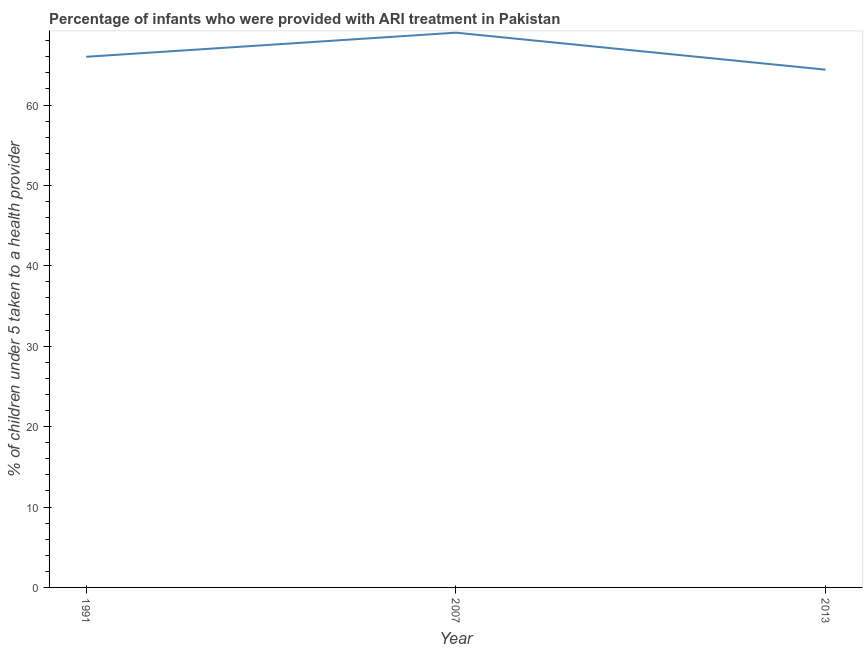What is the percentage of children who were provided with ari treatment in 2013?
Your answer should be compact. 64.4. Across all years, what is the maximum percentage of children who were provided with ari treatment?
Offer a terse response. 69. Across all years, what is the minimum percentage of children who were provided with ari treatment?
Offer a terse response. 64.4. In which year was the percentage of children who were provided with ari treatment maximum?
Offer a terse response. 2007. In which year was the percentage of children who were provided with ari treatment minimum?
Provide a succinct answer. 2013. What is the sum of the percentage of children who were provided with ari treatment?
Offer a terse response. 199.4. What is the difference between the percentage of children who were provided with ari treatment in 1991 and 2013?
Offer a terse response. 1.6. What is the average percentage of children who were provided with ari treatment per year?
Provide a short and direct response. 66.47. What is the median percentage of children who were provided with ari treatment?
Make the answer very short. 66. In how many years, is the percentage of children who were provided with ari treatment greater than 44 %?
Give a very brief answer. 3. What is the ratio of the percentage of children who were provided with ari treatment in 1991 to that in 2013?
Provide a succinct answer. 1.02. Is the percentage of children who were provided with ari treatment in 2007 less than that in 2013?
Your response must be concise. No. What is the difference between the highest and the lowest percentage of children who were provided with ari treatment?
Your response must be concise. 4.6. In how many years, is the percentage of children who were provided with ari treatment greater than the average percentage of children who were provided with ari treatment taken over all years?
Offer a terse response. 1. What is the title of the graph?
Your response must be concise. Percentage of infants who were provided with ARI treatment in Pakistan. What is the label or title of the X-axis?
Provide a short and direct response. Year. What is the label or title of the Y-axis?
Provide a succinct answer. % of children under 5 taken to a health provider. What is the % of children under 5 taken to a health provider of 1991?
Give a very brief answer. 66. What is the % of children under 5 taken to a health provider of 2013?
Keep it short and to the point. 64.4. What is the difference between the % of children under 5 taken to a health provider in 1991 and 2007?
Offer a terse response. -3. What is the difference between the % of children under 5 taken to a health provider in 1991 and 2013?
Provide a short and direct response. 1.6. What is the ratio of the % of children under 5 taken to a health provider in 2007 to that in 2013?
Make the answer very short. 1.07. 